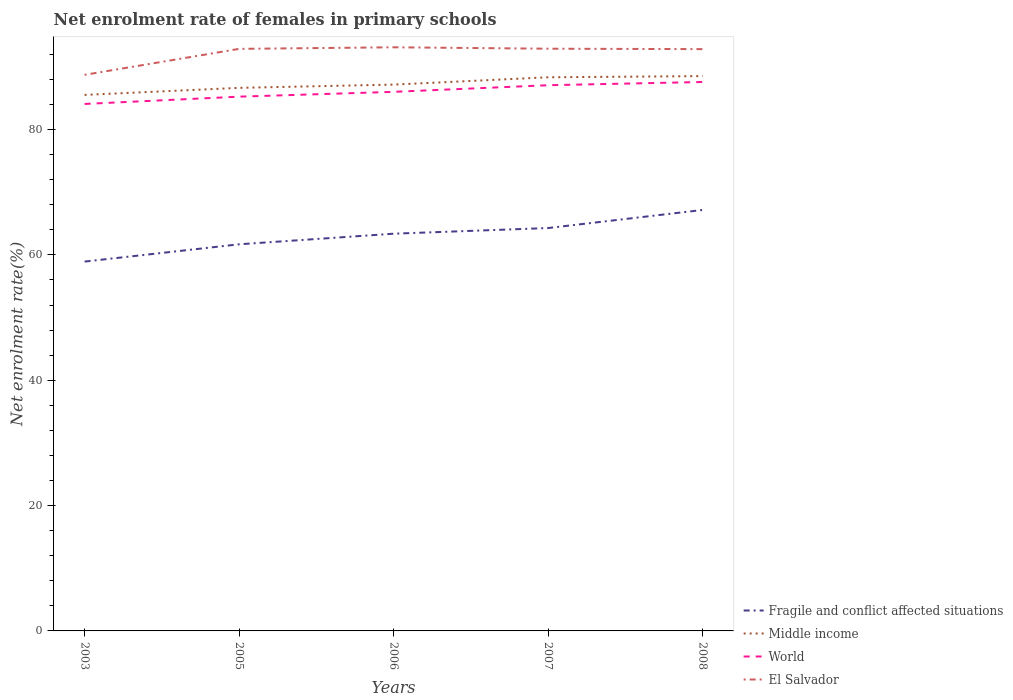Does the line corresponding to Middle income intersect with the line corresponding to El Salvador?
Make the answer very short. No. Is the number of lines equal to the number of legend labels?
Make the answer very short. Yes. Across all years, what is the maximum net enrolment rate of females in primary schools in Middle income?
Ensure brevity in your answer.  85.53. What is the total net enrolment rate of females in primary schools in World in the graph?
Offer a terse response. -1.93. What is the difference between the highest and the second highest net enrolment rate of females in primary schools in Middle income?
Ensure brevity in your answer.  3. Is the net enrolment rate of females in primary schools in Fragile and conflict affected situations strictly greater than the net enrolment rate of females in primary schools in Middle income over the years?
Give a very brief answer. Yes. How many years are there in the graph?
Your response must be concise. 5. Does the graph contain grids?
Provide a succinct answer. No. How are the legend labels stacked?
Ensure brevity in your answer.  Vertical. What is the title of the graph?
Provide a short and direct response. Net enrolment rate of females in primary schools. What is the label or title of the X-axis?
Offer a terse response. Years. What is the label or title of the Y-axis?
Provide a short and direct response. Net enrolment rate(%). What is the Net enrolment rate(%) of Fragile and conflict affected situations in 2003?
Offer a terse response. 58.93. What is the Net enrolment rate(%) of Middle income in 2003?
Provide a short and direct response. 85.53. What is the Net enrolment rate(%) of World in 2003?
Make the answer very short. 84.09. What is the Net enrolment rate(%) of El Salvador in 2003?
Offer a terse response. 88.73. What is the Net enrolment rate(%) in Fragile and conflict affected situations in 2005?
Your response must be concise. 61.69. What is the Net enrolment rate(%) of Middle income in 2005?
Your answer should be very brief. 86.66. What is the Net enrolment rate(%) in World in 2005?
Provide a short and direct response. 85.25. What is the Net enrolment rate(%) in El Salvador in 2005?
Give a very brief answer. 92.88. What is the Net enrolment rate(%) in Fragile and conflict affected situations in 2006?
Your response must be concise. 63.38. What is the Net enrolment rate(%) in Middle income in 2006?
Provide a succinct answer. 87.17. What is the Net enrolment rate(%) in World in 2006?
Ensure brevity in your answer.  86.02. What is the Net enrolment rate(%) in El Salvador in 2006?
Offer a terse response. 93.13. What is the Net enrolment rate(%) in Fragile and conflict affected situations in 2007?
Make the answer very short. 64.29. What is the Net enrolment rate(%) in Middle income in 2007?
Provide a succinct answer. 88.34. What is the Net enrolment rate(%) in World in 2007?
Offer a terse response. 87.08. What is the Net enrolment rate(%) of El Salvador in 2007?
Provide a succinct answer. 92.9. What is the Net enrolment rate(%) of Fragile and conflict affected situations in 2008?
Keep it short and to the point. 67.17. What is the Net enrolment rate(%) of Middle income in 2008?
Your response must be concise. 88.53. What is the Net enrolment rate(%) of World in 2008?
Make the answer very short. 87.59. What is the Net enrolment rate(%) of El Salvador in 2008?
Offer a terse response. 92.83. Across all years, what is the maximum Net enrolment rate(%) of Fragile and conflict affected situations?
Ensure brevity in your answer.  67.17. Across all years, what is the maximum Net enrolment rate(%) of Middle income?
Offer a terse response. 88.53. Across all years, what is the maximum Net enrolment rate(%) in World?
Ensure brevity in your answer.  87.59. Across all years, what is the maximum Net enrolment rate(%) in El Salvador?
Offer a very short reply. 93.13. Across all years, what is the minimum Net enrolment rate(%) in Fragile and conflict affected situations?
Your response must be concise. 58.93. Across all years, what is the minimum Net enrolment rate(%) of Middle income?
Ensure brevity in your answer.  85.53. Across all years, what is the minimum Net enrolment rate(%) in World?
Keep it short and to the point. 84.09. Across all years, what is the minimum Net enrolment rate(%) of El Salvador?
Ensure brevity in your answer.  88.73. What is the total Net enrolment rate(%) in Fragile and conflict affected situations in the graph?
Provide a short and direct response. 315.47. What is the total Net enrolment rate(%) in Middle income in the graph?
Offer a very short reply. 436.23. What is the total Net enrolment rate(%) of World in the graph?
Your answer should be compact. 430.02. What is the total Net enrolment rate(%) in El Salvador in the graph?
Offer a very short reply. 460.47. What is the difference between the Net enrolment rate(%) in Fragile and conflict affected situations in 2003 and that in 2005?
Provide a short and direct response. -2.76. What is the difference between the Net enrolment rate(%) in Middle income in 2003 and that in 2005?
Give a very brief answer. -1.12. What is the difference between the Net enrolment rate(%) in World in 2003 and that in 2005?
Provide a short and direct response. -1.16. What is the difference between the Net enrolment rate(%) of El Salvador in 2003 and that in 2005?
Your answer should be very brief. -4.14. What is the difference between the Net enrolment rate(%) of Fragile and conflict affected situations in 2003 and that in 2006?
Make the answer very short. -4.45. What is the difference between the Net enrolment rate(%) of Middle income in 2003 and that in 2006?
Your response must be concise. -1.64. What is the difference between the Net enrolment rate(%) of World in 2003 and that in 2006?
Offer a very short reply. -1.93. What is the difference between the Net enrolment rate(%) of El Salvador in 2003 and that in 2006?
Keep it short and to the point. -4.39. What is the difference between the Net enrolment rate(%) of Fragile and conflict affected situations in 2003 and that in 2007?
Provide a short and direct response. -5.35. What is the difference between the Net enrolment rate(%) in Middle income in 2003 and that in 2007?
Your response must be concise. -2.81. What is the difference between the Net enrolment rate(%) in World in 2003 and that in 2007?
Provide a short and direct response. -2.99. What is the difference between the Net enrolment rate(%) of El Salvador in 2003 and that in 2007?
Provide a short and direct response. -4.17. What is the difference between the Net enrolment rate(%) in Fragile and conflict affected situations in 2003 and that in 2008?
Your response must be concise. -8.24. What is the difference between the Net enrolment rate(%) in Middle income in 2003 and that in 2008?
Make the answer very short. -3. What is the difference between the Net enrolment rate(%) in World in 2003 and that in 2008?
Keep it short and to the point. -3.51. What is the difference between the Net enrolment rate(%) of El Salvador in 2003 and that in 2008?
Make the answer very short. -4.1. What is the difference between the Net enrolment rate(%) of Fragile and conflict affected situations in 2005 and that in 2006?
Offer a terse response. -1.69. What is the difference between the Net enrolment rate(%) of Middle income in 2005 and that in 2006?
Provide a succinct answer. -0.52. What is the difference between the Net enrolment rate(%) of World in 2005 and that in 2006?
Your answer should be compact. -0.77. What is the difference between the Net enrolment rate(%) of El Salvador in 2005 and that in 2006?
Your response must be concise. -0.25. What is the difference between the Net enrolment rate(%) of Fragile and conflict affected situations in 2005 and that in 2007?
Keep it short and to the point. -2.6. What is the difference between the Net enrolment rate(%) of Middle income in 2005 and that in 2007?
Offer a very short reply. -1.69. What is the difference between the Net enrolment rate(%) in World in 2005 and that in 2007?
Give a very brief answer. -1.83. What is the difference between the Net enrolment rate(%) in El Salvador in 2005 and that in 2007?
Offer a very short reply. -0.02. What is the difference between the Net enrolment rate(%) in Fragile and conflict affected situations in 2005 and that in 2008?
Provide a short and direct response. -5.48. What is the difference between the Net enrolment rate(%) in Middle income in 2005 and that in 2008?
Offer a very short reply. -1.87. What is the difference between the Net enrolment rate(%) in World in 2005 and that in 2008?
Your response must be concise. -2.34. What is the difference between the Net enrolment rate(%) in El Salvador in 2005 and that in 2008?
Your response must be concise. 0.04. What is the difference between the Net enrolment rate(%) of Fragile and conflict affected situations in 2006 and that in 2007?
Ensure brevity in your answer.  -0.91. What is the difference between the Net enrolment rate(%) of Middle income in 2006 and that in 2007?
Make the answer very short. -1.17. What is the difference between the Net enrolment rate(%) in World in 2006 and that in 2007?
Provide a succinct answer. -1.06. What is the difference between the Net enrolment rate(%) of El Salvador in 2006 and that in 2007?
Make the answer very short. 0.23. What is the difference between the Net enrolment rate(%) in Fragile and conflict affected situations in 2006 and that in 2008?
Provide a short and direct response. -3.79. What is the difference between the Net enrolment rate(%) of Middle income in 2006 and that in 2008?
Offer a very short reply. -1.36. What is the difference between the Net enrolment rate(%) in World in 2006 and that in 2008?
Ensure brevity in your answer.  -1.57. What is the difference between the Net enrolment rate(%) in El Salvador in 2006 and that in 2008?
Keep it short and to the point. 0.29. What is the difference between the Net enrolment rate(%) in Fragile and conflict affected situations in 2007 and that in 2008?
Your response must be concise. -2.89. What is the difference between the Net enrolment rate(%) in Middle income in 2007 and that in 2008?
Provide a succinct answer. -0.19. What is the difference between the Net enrolment rate(%) in World in 2007 and that in 2008?
Offer a very short reply. -0.51. What is the difference between the Net enrolment rate(%) in El Salvador in 2007 and that in 2008?
Provide a short and direct response. 0.07. What is the difference between the Net enrolment rate(%) of Fragile and conflict affected situations in 2003 and the Net enrolment rate(%) of Middle income in 2005?
Make the answer very short. -27.72. What is the difference between the Net enrolment rate(%) in Fragile and conflict affected situations in 2003 and the Net enrolment rate(%) in World in 2005?
Give a very brief answer. -26.32. What is the difference between the Net enrolment rate(%) in Fragile and conflict affected situations in 2003 and the Net enrolment rate(%) in El Salvador in 2005?
Provide a short and direct response. -33.94. What is the difference between the Net enrolment rate(%) of Middle income in 2003 and the Net enrolment rate(%) of World in 2005?
Keep it short and to the point. 0.28. What is the difference between the Net enrolment rate(%) of Middle income in 2003 and the Net enrolment rate(%) of El Salvador in 2005?
Give a very brief answer. -7.34. What is the difference between the Net enrolment rate(%) in World in 2003 and the Net enrolment rate(%) in El Salvador in 2005?
Your answer should be compact. -8.79. What is the difference between the Net enrolment rate(%) in Fragile and conflict affected situations in 2003 and the Net enrolment rate(%) in Middle income in 2006?
Make the answer very short. -28.24. What is the difference between the Net enrolment rate(%) in Fragile and conflict affected situations in 2003 and the Net enrolment rate(%) in World in 2006?
Keep it short and to the point. -27.08. What is the difference between the Net enrolment rate(%) of Fragile and conflict affected situations in 2003 and the Net enrolment rate(%) of El Salvador in 2006?
Make the answer very short. -34.19. What is the difference between the Net enrolment rate(%) of Middle income in 2003 and the Net enrolment rate(%) of World in 2006?
Offer a very short reply. -0.48. What is the difference between the Net enrolment rate(%) in Middle income in 2003 and the Net enrolment rate(%) in El Salvador in 2006?
Provide a short and direct response. -7.59. What is the difference between the Net enrolment rate(%) of World in 2003 and the Net enrolment rate(%) of El Salvador in 2006?
Ensure brevity in your answer.  -9.04. What is the difference between the Net enrolment rate(%) in Fragile and conflict affected situations in 2003 and the Net enrolment rate(%) in Middle income in 2007?
Your answer should be very brief. -29.41. What is the difference between the Net enrolment rate(%) in Fragile and conflict affected situations in 2003 and the Net enrolment rate(%) in World in 2007?
Provide a succinct answer. -28.14. What is the difference between the Net enrolment rate(%) in Fragile and conflict affected situations in 2003 and the Net enrolment rate(%) in El Salvador in 2007?
Ensure brevity in your answer.  -33.97. What is the difference between the Net enrolment rate(%) of Middle income in 2003 and the Net enrolment rate(%) of World in 2007?
Keep it short and to the point. -1.54. What is the difference between the Net enrolment rate(%) of Middle income in 2003 and the Net enrolment rate(%) of El Salvador in 2007?
Make the answer very short. -7.37. What is the difference between the Net enrolment rate(%) of World in 2003 and the Net enrolment rate(%) of El Salvador in 2007?
Provide a succinct answer. -8.82. What is the difference between the Net enrolment rate(%) in Fragile and conflict affected situations in 2003 and the Net enrolment rate(%) in Middle income in 2008?
Your answer should be very brief. -29.6. What is the difference between the Net enrolment rate(%) of Fragile and conflict affected situations in 2003 and the Net enrolment rate(%) of World in 2008?
Your response must be concise. -28.66. What is the difference between the Net enrolment rate(%) in Fragile and conflict affected situations in 2003 and the Net enrolment rate(%) in El Salvador in 2008?
Give a very brief answer. -33.9. What is the difference between the Net enrolment rate(%) in Middle income in 2003 and the Net enrolment rate(%) in World in 2008?
Your answer should be compact. -2.06. What is the difference between the Net enrolment rate(%) in Middle income in 2003 and the Net enrolment rate(%) in El Salvador in 2008?
Offer a terse response. -7.3. What is the difference between the Net enrolment rate(%) of World in 2003 and the Net enrolment rate(%) of El Salvador in 2008?
Make the answer very short. -8.75. What is the difference between the Net enrolment rate(%) of Fragile and conflict affected situations in 2005 and the Net enrolment rate(%) of Middle income in 2006?
Offer a very short reply. -25.48. What is the difference between the Net enrolment rate(%) of Fragile and conflict affected situations in 2005 and the Net enrolment rate(%) of World in 2006?
Ensure brevity in your answer.  -24.33. What is the difference between the Net enrolment rate(%) of Fragile and conflict affected situations in 2005 and the Net enrolment rate(%) of El Salvador in 2006?
Provide a succinct answer. -31.43. What is the difference between the Net enrolment rate(%) in Middle income in 2005 and the Net enrolment rate(%) in World in 2006?
Ensure brevity in your answer.  0.64. What is the difference between the Net enrolment rate(%) of Middle income in 2005 and the Net enrolment rate(%) of El Salvador in 2006?
Give a very brief answer. -6.47. What is the difference between the Net enrolment rate(%) of World in 2005 and the Net enrolment rate(%) of El Salvador in 2006?
Provide a short and direct response. -7.88. What is the difference between the Net enrolment rate(%) of Fragile and conflict affected situations in 2005 and the Net enrolment rate(%) of Middle income in 2007?
Provide a short and direct response. -26.65. What is the difference between the Net enrolment rate(%) in Fragile and conflict affected situations in 2005 and the Net enrolment rate(%) in World in 2007?
Make the answer very short. -25.38. What is the difference between the Net enrolment rate(%) of Fragile and conflict affected situations in 2005 and the Net enrolment rate(%) of El Salvador in 2007?
Provide a short and direct response. -31.21. What is the difference between the Net enrolment rate(%) in Middle income in 2005 and the Net enrolment rate(%) in World in 2007?
Give a very brief answer. -0.42. What is the difference between the Net enrolment rate(%) in Middle income in 2005 and the Net enrolment rate(%) in El Salvador in 2007?
Keep it short and to the point. -6.25. What is the difference between the Net enrolment rate(%) of World in 2005 and the Net enrolment rate(%) of El Salvador in 2007?
Make the answer very short. -7.65. What is the difference between the Net enrolment rate(%) of Fragile and conflict affected situations in 2005 and the Net enrolment rate(%) of Middle income in 2008?
Your response must be concise. -26.84. What is the difference between the Net enrolment rate(%) in Fragile and conflict affected situations in 2005 and the Net enrolment rate(%) in World in 2008?
Provide a succinct answer. -25.9. What is the difference between the Net enrolment rate(%) in Fragile and conflict affected situations in 2005 and the Net enrolment rate(%) in El Salvador in 2008?
Your answer should be compact. -31.14. What is the difference between the Net enrolment rate(%) of Middle income in 2005 and the Net enrolment rate(%) of World in 2008?
Offer a very short reply. -0.94. What is the difference between the Net enrolment rate(%) in Middle income in 2005 and the Net enrolment rate(%) in El Salvador in 2008?
Your response must be concise. -6.18. What is the difference between the Net enrolment rate(%) of World in 2005 and the Net enrolment rate(%) of El Salvador in 2008?
Ensure brevity in your answer.  -7.58. What is the difference between the Net enrolment rate(%) in Fragile and conflict affected situations in 2006 and the Net enrolment rate(%) in Middle income in 2007?
Give a very brief answer. -24.96. What is the difference between the Net enrolment rate(%) in Fragile and conflict affected situations in 2006 and the Net enrolment rate(%) in World in 2007?
Keep it short and to the point. -23.69. What is the difference between the Net enrolment rate(%) in Fragile and conflict affected situations in 2006 and the Net enrolment rate(%) in El Salvador in 2007?
Your response must be concise. -29.52. What is the difference between the Net enrolment rate(%) of Middle income in 2006 and the Net enrolment rate(%) of World in 2007?
Your answer should be compact. 0.1. What is the difference between the Net enrolment rate(%) of Middle income in 2006 and the Net enrolment rate(%) of El Salvador in 2007?
Keep it short and to the point. -5.73. What is the difference between the Net enrolment rate(%) in World in 2006 and the Net enrolment rate(%) in El Salvador in 2007?
Offer a terse response. -6.88. What is the difference between the Net enrolment rate(%) in Fragile and conflict affected situations in 2006 and the Net enrolment rate(%) in Middle income in 2008?
Keep it short and to the point. -25.15. What is the difference between the Net enrolment rate(%) in Fragile and conflict affected situations in 2006 and the Net enrolment rate(%) in World in 2008?
Make the answer very short. -24.21. What is the difference between the Net enrolment rate(%) of Fragile and conflict affected situations in 2006 and the Net enrolment rate(%) of El Salvador in 2008?
Provide a succinct answer. -29.45. What is the difference between the Net enrolment rate(%) in Middle income in 2006 and the Net enrolment rate(%) in World in 2008?
Keep it short and to the point. -0.42. What is the difference between the Net enrolment rate(%) of Middle income in 2006 and the Net enrolment rate(%) of El Salvador in 2008?
Provide a short and direct response. -5.66. What is the difference between the Net enrolment rate(%) in World in 2006 and the Net enrolment rate(%) in El Salvador in 2008?
Offer a terse response. -6.82. What is the difference between the Net enrolment rate(%) in Fragile and conflict affected situations in 2007 and the Net enrolment rate(%) in Middle income in 2008?
Your answer should be very brief. -24.24. What is the difference between the Net enrolment rate(%) of Fragile and conflict affected situations in 2007 and the Net enrolment rate(%) of World in 2008?
Provide a short and direct response. -23.3. What is the difference between the Net enrolment rate(%) of Fragile and conflict affected situations in 2007 and the Net enrolment rate(%) of El Salvador in 2008?
Keep it short and to the point. -28.55. What is the difference between the Net enrolment rate(%) in Middle income in 2007 and the Net enrolment rate(%) in World in 2008?
Provide a succinct answer. 0.75. What is the difference between the Net enrolment rate(%) in Middle income in 2007 and the Net enrolment rate(%) in El Salvador in 2008?
Your answer should be compact. -4.49. What is the difference between the Net enrolment rate(%) in World in 2007 and the Net enrolment rate(%) in El Salvador in 2008?
Make the answer very short. -5.76. What is the average Net enrolment rate(%) in Fragile and conflict affected situations per year?
Your answer should be compact. 63.09. What is the average Net enrolment rate(%) of Middle income per year?
Your answer should be compact. 87.25. What is the average Net enrolment rate(%) of World per year?
Ensure brevity in your answer.  86. What is the average Net enrolment rate(%) in El Salvador per year?
Your response must be concise. 92.09. In the year 2003, what is the difference between the Net enrolment rate(%) in Fragile and conflict affected situations and Net enrolment rate(%) in Middle income?
Your answer should be very brief. -26.6. In the year 2003, what is the difference between the Net enrolment rate(%) of Fragile and conflict affected situations and Net enrolment rate(%) of World?
Your answer should be compact. -25.15. In the year 2003, what is the difference between the Net enrolment rate(%) in Fragile and conflict affected situations and Net enrolment rate(%) in El Salvador?
Your answer should be compact. -29.8. In the year 2003, what is the difference between the Net enrolment rate(%) in Middle income and Net enrolment rate(%) in World?
Your answer should be compact. 1.45. In the year 2003, what is the difference between the Net enrolment rate(%) in Middle income and Net enrolment rate(%) in El Salvador?
Give a very brief answer. -3.2. In the year 2003, what is the difference between the Net enrolment rate(%) of World and Net enrolment rate(%) of El Salvador?
Provide a succinct answer. -4.65. In the year 2005, what is the difference between the Net enrolment rate(%) of Fragile and conflict affected situations and Net enrolment rate(%) of Middle income?
Provide a short and direct response. -24.96. In the year 2005, what is the difference between the Net enrolment rate(%) of Fragile and conflict affected situations and Net enrolment rate(%) of World?
Offer a terse response. -23.56. In the year 2005, what is the difference between the Net enrolment rate(%) of Fragile and conflict affected situations and Net enrolment rate(%) of El Salvador?
Make the answer very short. -31.18. In the year 2005, what is the difference between the Net enrolment rate(%) in Middle income and Net enrolment rate(%) in World?
Make the answer very short. 1.41. In the year 2005, what is the difference between the Net enrolment rate(%) in Middle income and Net enrolment rate(%) in El Salvador?
Provide a succinct answer. -6.22. In the year 2005, what is the difference between the Net enrolment rate(%) in World and Net enrolment rate(%) in El Salvador?
Give a very brief answer. -7.63. In the year 2006, what is the difference between the Net enrolment rate(%) of Fragile and conflict affected situations and Net enrolment rate(%) of Middle income?
Your answer should be compact. -23.79. In the year 2006, what is the difference between the Net enrolment rate(%) of Fragile and conflict affected situations and Net enrolment rate(%) of World?
Offer a very short reply. -22.63. In the year 2006, what is the difference between the Net enrolment rate(%) in Fragile and conflict affected situations and Net enrolment rate(%) in El Salvador?
Provide a short and direct response. -29.74. In the year 2006, what is the difference between the Net enrolment rate(%) of Middle income and Net enrolment rate(%) of World?
Keep it short and to the point. 1.16. In the year 2006, what is the difference between the Net enrolment rate(%) of Middle income and Net enrolment rate(%) of El Salvador?
Provide a short and direct response. -5.95. In the year 2006, what is the difference between the Net enrolment rate(%) of World and Net enrolment rate(%) of El Salvador?
Offer a terse response. -7.11. In the year 2007, what is the difference between the Net enrolment rate(%) in Fragile and conflict affected situations and Net enrolment rate(%) in Middle income?
Give a very brief answer. -24.05. In the year 2007, what is the difference between the Net enrolment rate(%) in Fragile and conflict affected situations and Net enrolment rate(%) in World?
Give a very brief answer. -22.79. In the year 2007, what is the difference between the Net enrolment rate(%) in Fragile and conflict affected situations and Net enrolment rate(%) in El Salvador?
Offer a terse response. -28.61. In the year 2007, what is the difference between the Net enrolment rate(%) of Middle income and Net enrolment rate(%) of World?
Your response must be concise. 1.26. In the year 2007, what is the difference between the Net enrolment rate(%) in Middle income and Net enrolment rate(%) in El Salvador?
Provide a succinct answer. -4.56. In the year 2007, what is the difference between the Net enrolment rate(%) of World and Net enrolment rate(%) of El Salvador?
Offer a terse response. -5.82. In the year 2008, what is the difference between the Net enrolment rate(%) of Fragile and conflict affected situations and Net enrolment rate(%) of Middle income?
Give a very brief answer. -21.35. In the year 2008, what is the difference between the Net enrolment rate(%) of Fragile and conflict affected situations and Net enrolment rate(%) of World?
Make the answer very short. -20.42. In the year 2008, what is the difference between the Net enrolment rate(%) of Fragile and conflict affected situations and Net enrolment rate(%) of El Salvador?
Offer a terse response. -25.66. In the year 2008, what is the difference between the Net enrolment rate(%) of Middle income and Net enrolment rate(%) of World?
Offer a terse response. 0.94. In the year 2008, what is the difference between the Net enrolment rate(%) of Middle income and Net enrolment rate(%) of El Salvador?
Your answer should be very brief. -4.31. In the year 2008, what is the difference between the Net enrolment rate(%) in World and Net enrolment rate(%) in El Salvador?
Your answer should be compact. -5.24. What is the ratio of the Net enrolment rate(%) in Fragile and conflict affected situations in 2003 to that in 2005?
Offer a terse response. 0.96. What is the ratio of the Net enrolment rate(%) in World in 2003 to that in 2005?
Your answer should be compact. 0.99. What is the ratio of the Net enrolment rate(%) of El Salvador in 2003 to that in 2005?
Your answer should be very brief. 0.96. What is the ratio of the Net enrolment rate(%) of Fragile and conflict affected situations in 2003 to that in 2006?
Your response must be concise. 0.93. What is the ratio of the Net enrolment rate(%) of Middle income in 2003 to that in 2006?
Ensure brevity in your answer.  0.98. What is the ratio of the Net enrolment rate(%) in World in 2003 to that in 2006?
Your answer should be very brief. 0.98. What is the ratio of the Net enrolment rate(%) of El Salvador in 2003 to that in 2006?
Offer a very short reply. 0.95. What is the ratio of the Net enrolment rate(%) in Fragile and conflict affected situations in 2003 to that in 2007?
Provide a succinct answer. 0.92. What is the ratio of the Net enrolment rate(%) in Middle income in 2003 to that in 2007?
Provide a succinct answer. 0.97. What is the ratio of the Net enrolment rate(%) of World in 2003 to that in 2007?
Give a very brief answer. 0.97. What is the ratio of the Net enrolment rate(%) in El Salvador in 2003 to that in 2007?
Ensure brevity in your answer.  0.96. What is the ratio of the Net enrolment rate(%) in Fragile and conflict affected situations in 2003 to that in 2008?
Ensure brevity in your answer.  0.88. What is the ratio of the Net enrolment rate(%) of Middle income in 2003 to that in 2008?
Provide a succinct answer. 0.97. What is the ratio of the Net enrolment rate(%) of El Salvador in 2003 to that in 2008?
Provide a short and direct response. 0.96. What is the ratio of the Net enrolment rate(%) of Fragile and conflict affected situations in 2005 to that in 2006?
Provide a short and direct response. 0.97. What is the ratio of the Net enrolment rate(%) of Middle income in 2005 to that in 2006?
Give a very brief answer. 0.99. What is the ratio of the Net enrolment rate(%) of World in 2005 to that in 2006?
Ensure brevity in your answer.  0.99. What is the ratio of the Net enrolment rate(%) of El Salvador in 2005 to that in 2006?
Offer a terse response. 1. What is the ratio of the Net enrolment rate(%) of Fragile and conflict affected situations in 2005 to that in 2007?
Make the answer very short. 0.96. What is the ratio of the Net enrolment rate(%) in Middle income in 2005 to that in 2007?
Offer a very short reply. 0.98. What is the ratio of the Net enrolment rate(%) in El Salvador in 2005 to that in 2007?
Ensure brevity in your answer.  1. What is the ratio of the Net enrolment rate(%) in Fragile and conflict affected situations in 2005 to that in 2008?
Your answer should be compact. 0.92. What is the ratio of the Net enrolment rate(%) in Middle income in 2005 to that in 2008?
Ensure brevity in your answer.  0.98. What is the ratio of the Net enrolment rate(%) in World in 2005 to that in 2008?
Give a very brief answer. 0.97. What is the ratio of the Net enrolment rate(%) of El Salvador in 2005 to that in 2008?
Keep it short and to the point. 1. What is the ratio of the Net enrolment rate(%) in Fragile and conflict affected situations in 2006 to that in 2007?
Your response must be concise. 0.99. What is the ratio of the Net enrolment rate(%) of Middle income in 2006 to that in 2007?
Ensure brevity in your answer.  0.99. What is the ratio of the Net enrolment rate(%) in World in 2006 to that in 2007?
Provide a succinct answer. 0.99. What is the ratio of the Net enrolment rate(%) of El Salvador in 2006 to that in 2007?
Your answer should be very brief. 1. What is the ratio of the Net enrolment rate(%) in Fragile and conflict affected situations in 2006 to that in 2008?
Keep it short and to the point. 0.94. What is the ratio of the Net enrolment rate(%) of Middle income in 2006 to that in 2008?
Ensure brevity in your answer.  0.98. What is the ratio of the Net enrolment rate(%) of El Salvador in 2006 to that in 2008?
Keep it short and to the point. 1. What is the ratio of the Net enrolment rate(%) in World in 2007 to that in 2008?
Offer a very short reply. 0.99. What is the difference between the highest and the second highest Net enrolment rate(%) in Fragile and conflict affected situations?
Keep it short and to the point. 2.89. What is the difference between the highest and the second highest Net enrolment rate(%) in Middle income?
Offer a very short reply. 0.19. What is the difference between the highest and the second highest Net enrolment rate(%) in World?
Keep it short and to the point. 0.51. What is the difference between the highest and the second highest Net enrolment rate(%) in El Salvador?
Give a very brief answer. 0.23. What is the difference between the highest and the lowest Net enrolment rate(%) of Fragile and conflict affected situations?
Make the answer very short. 8.24. What is the difference between the highest and the lowest Net enrolment rate(%) in Middle income?
Make the answer very short. 3. What is the difference between the highest and the lowest Net enrolment rate(%) in World?
Your answer should be very brief. 3.51. What is the difference between the highest and the lowest Net enrolment rate(%) in El Salvador?
Give a very brief answer. 4.39. 